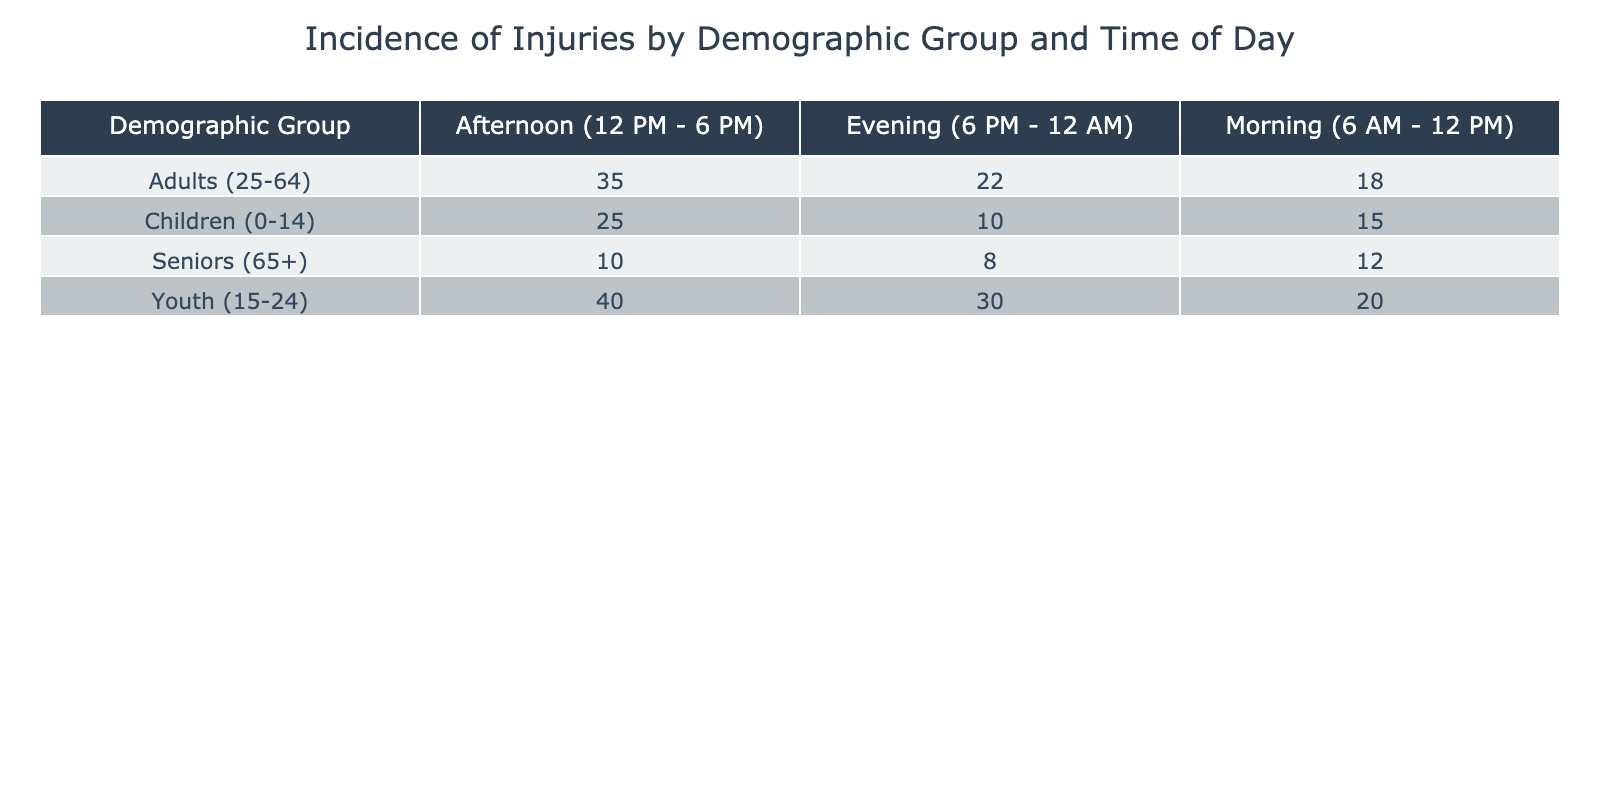What demographic group has the highest incidence of injuries in the afternoon? Looking at the "Afternoon" column, the group with the highest incidence of injuries is the "Youth (15-24)" category with 40 injuries reported.
Answer: Youth (15-24) What is the total incidence of injuries among children during all times of the day? To find the total for children, I add up the incidents: 15 (Morning) + 25 (Afternoon) + 10 (Evening) = 50.
Answer: 50 True or False: Seniors have more incidents of injuries in the morning than in the evening. In the morning, seniors had 12 injuries, while in the evening they had 8. Since 12 is greater than 8, the statement is true.
Answer: True What is the difference in the total incidence of injuries between adults and seniors in the evening? First, I find the evening incidence for both groups: Adults had 22 injuries, and Seniors had 8. The difference is 22 - 8 = 14.
Answer: 14 What demographic group has the lowest incidence of injuries in the morning? In the "Morning" column, I check the values: Children (15), Youth (20), Adults (18), Seniors (12). The lowest value is 12, which is for Seniors.
Answer: Seniors (65+) What is the average number of injuries for Youth (15-24) across all times of the day? For Youth, I sum the injuries across the three times: 20 (Morning) + 40 (Afternoon) + 30 (Evening) = 90. There are three data points, so I divide 90 by 3, giving an average of 30.
Answer: 30 True or False: There are fewer total injuries among adults compared to children during the afternoon. Adults have 35 injuries in the afternoon, while children have 25. Since 35 is greater than 25, the statement is false.
Answer: False How do the total injuries for seniors compare to the total injuries for adults in all time periods combined? For Seniors, the totals are 12 (Morning) + 10 (Afternoon) + 8 (Evening) = 30. For Adults, the totals are 18 (Morning) + 35 (Afternoon) + 22 (Evening) = 75. Since 30 is less than 75, seniors have fewer injuries than adults.
Answer: Seniors have fewer injuries than Adults 